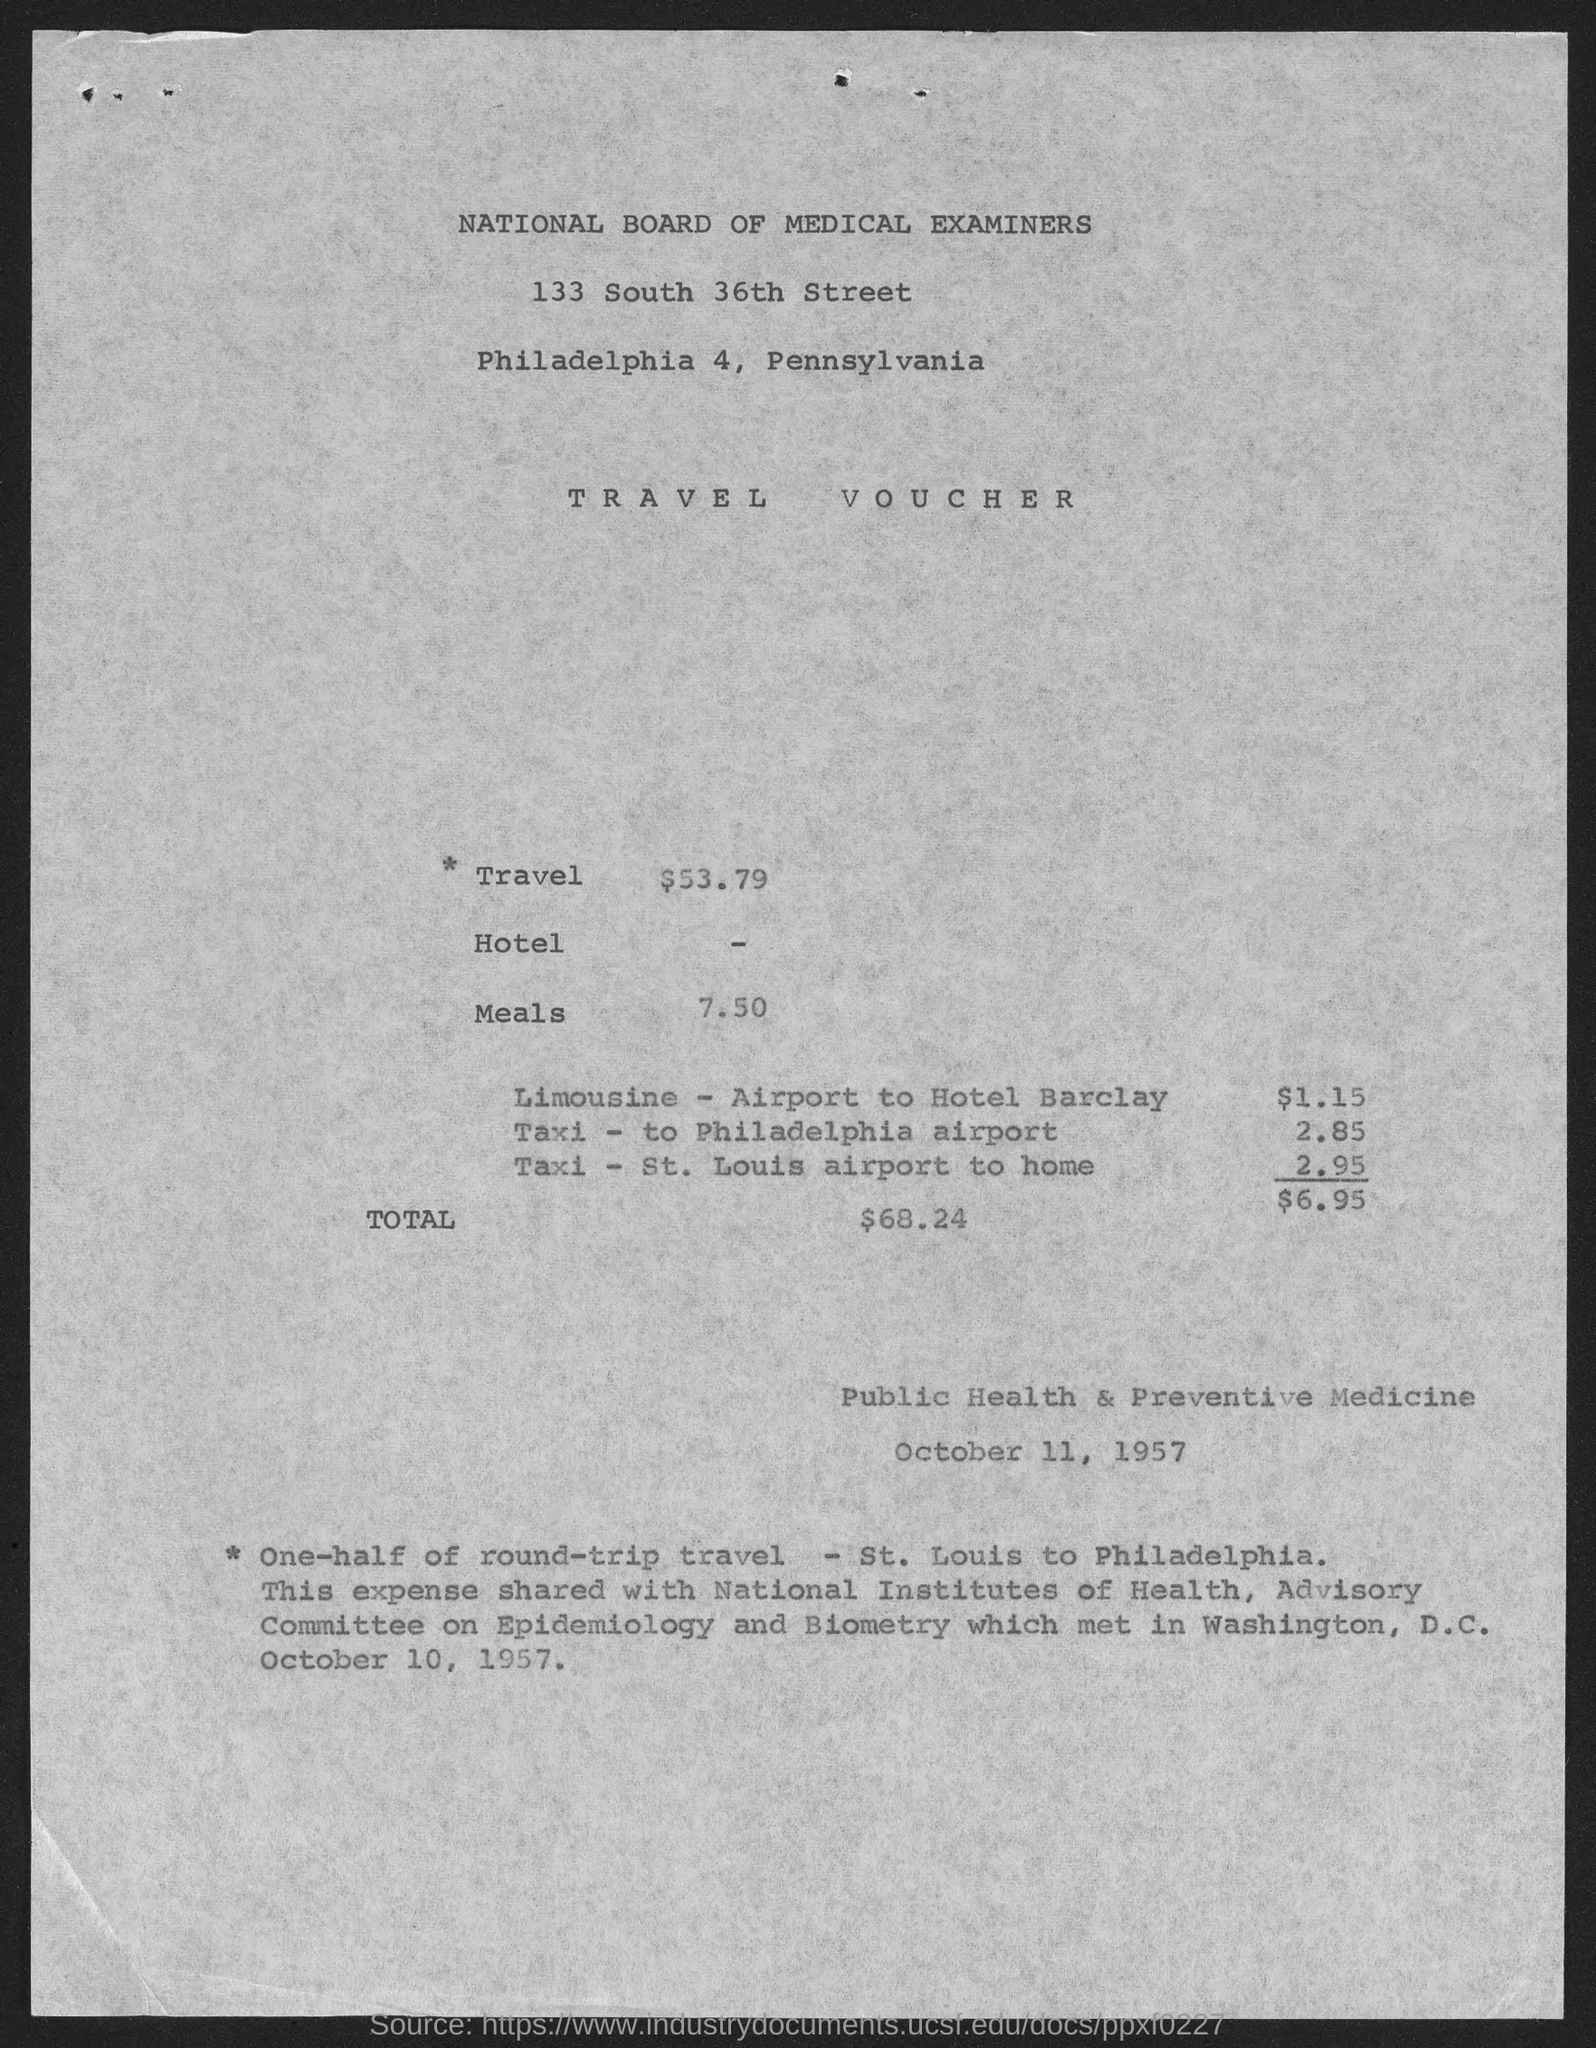Point out several critical features in this image. The date is October 11, 1957. The document pertains to a travel voucher. 